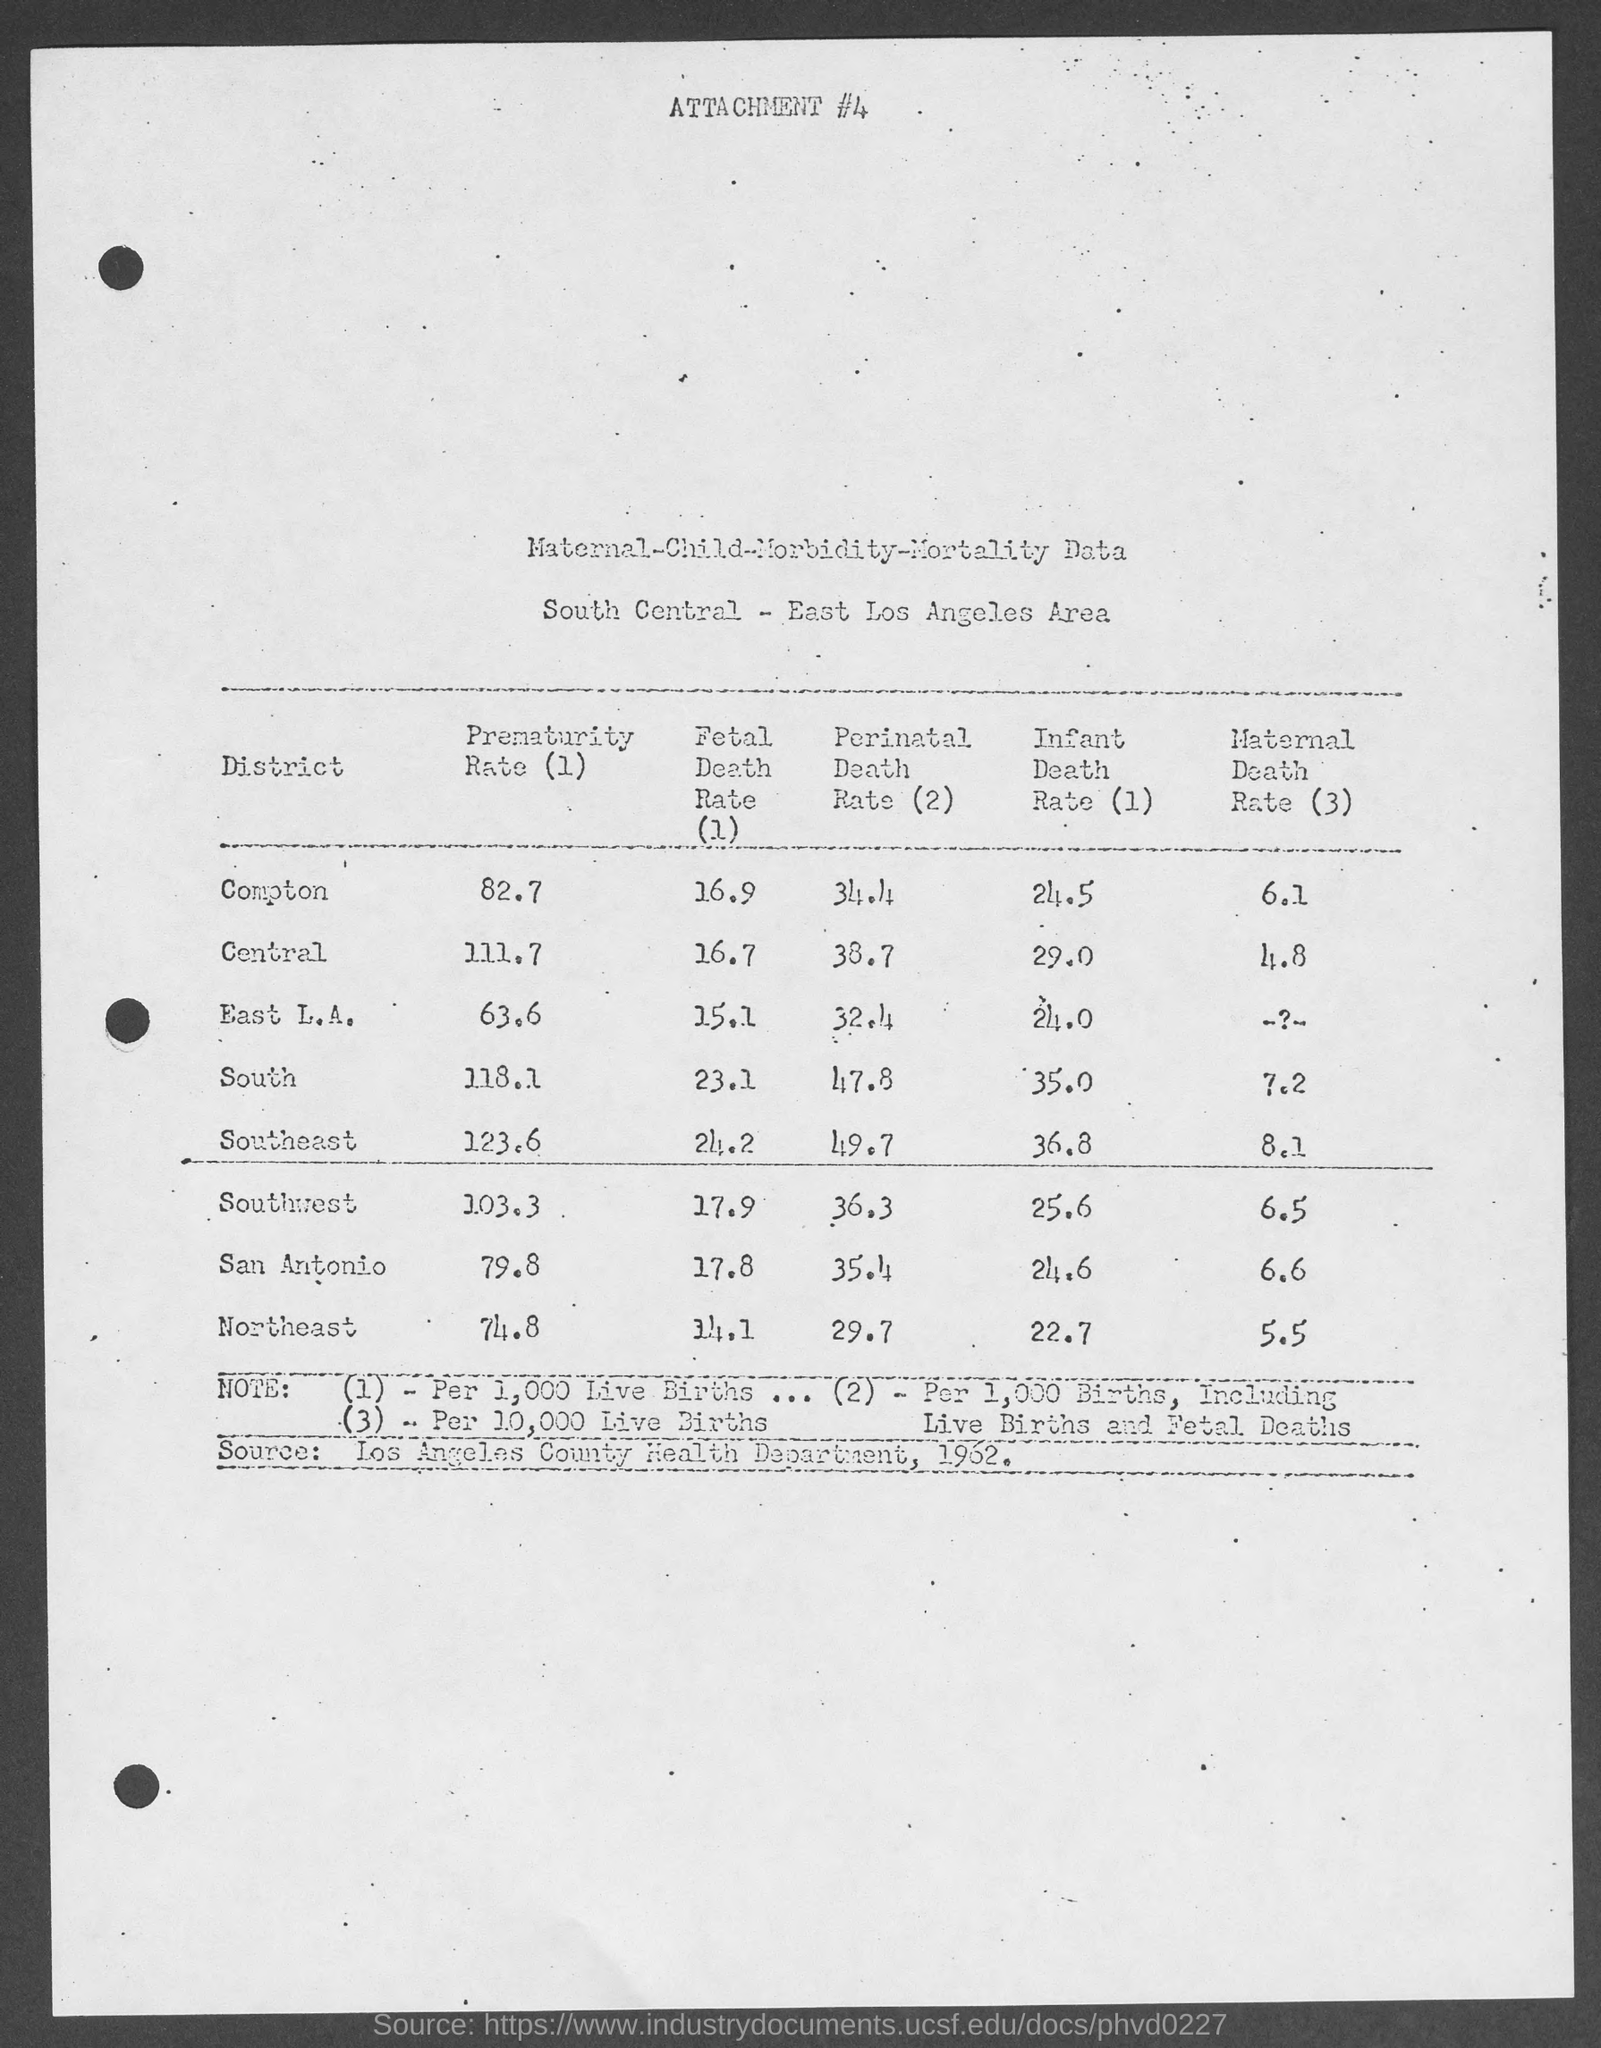Point out several critical features in this image. The infant death rate in South is 35.0. The preterm birth rate in East Los Angeles is 63.6%. The attachment #4 refers to maternal-child morbidity and mortality data. The maternal death rate in Southeast is 8.1 per 100,000 live births. 